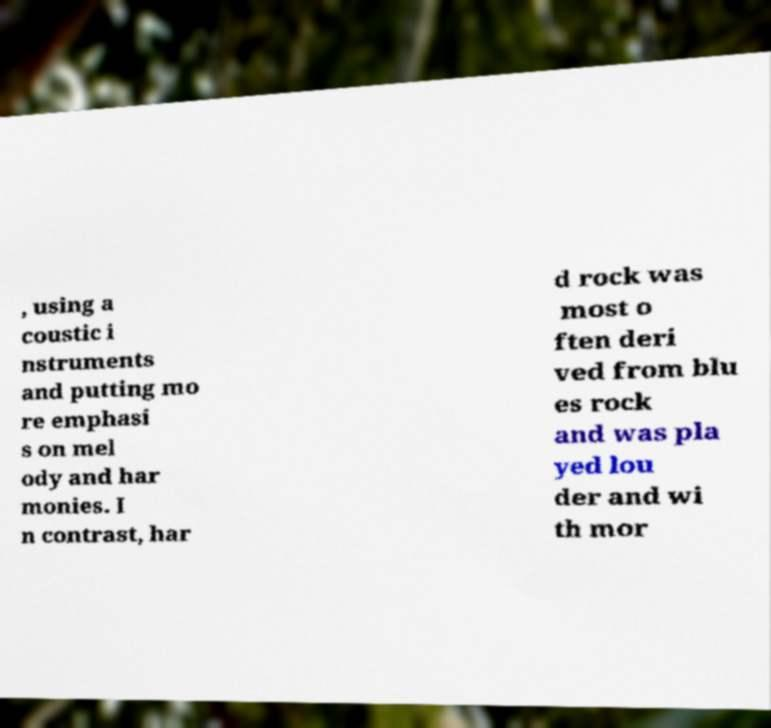Could you extract and type out the text from this image? , using a coustic i nstruments and putting mo re emphasi s on mel ody and har monies. I n contrast, har d rock was most o ften deri ved from blu es rock and was pla yed lou der and wi th mor 